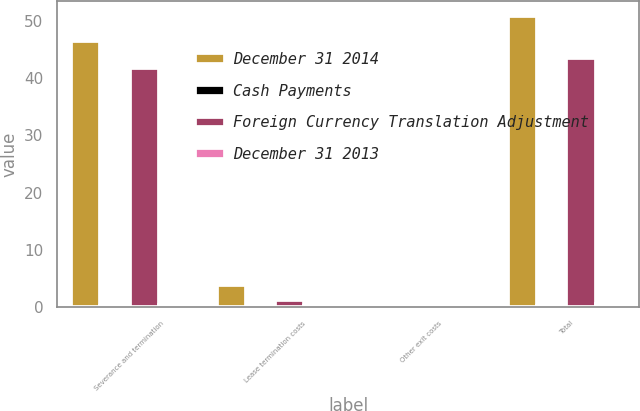<chart> <loc_0><loc_0><loc_500><loc_500><stacked_bar_chart><ecel><fcel>Severance and termination<fcel>Lease termination costs<fcel>Other exit costs<fcel>Total<nl><fcel>December 31 2014<fcel>46.5<fcel>3.9<fcel>0.5<fcel>50.9<nl><fcel>Cash Payments<fcel>0.1<fcel>0<fcel>0<fcel>0.1<nl><fcel>Foreign Currency Translation Adjustment<fcel>41.8<fcel>1.2<fcel>0.5<fcel>43.5<nl><fcel>December 31 2013<fcel>0.4<fcel>0.1<fcel>0<fcel>0.5<nl></chart> 